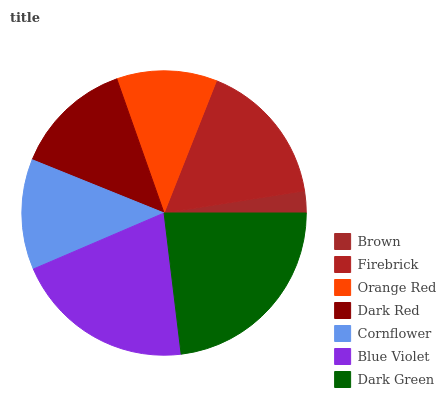Is Brown the minimum?
Answer yes or no. Yes. Is Dark Green the maximum?
Answer yes or no. Yes. Is Firebrick the minimum?
Answer yes or no. No. Is Firebrick the maximum?
Answer yes or no. No. Is Firebrick greater than Brown?
Answer yes or no. Yes. Is Brown less than Firebrick?
Answer yes or no. Yes. Is Brown greater than Firebrick?
Answer yes or no. No. Is Firebrick less than Brown?
Answer yes or no. No. Is Dark Red the high median?
Answer yes or no. Yes. Is Dark Red the low median?
Answer yes or no. Yes. Is Orange Red the high median?
Answer yes or no. No. Is Brown the low median?
Answer yes or no. No. 